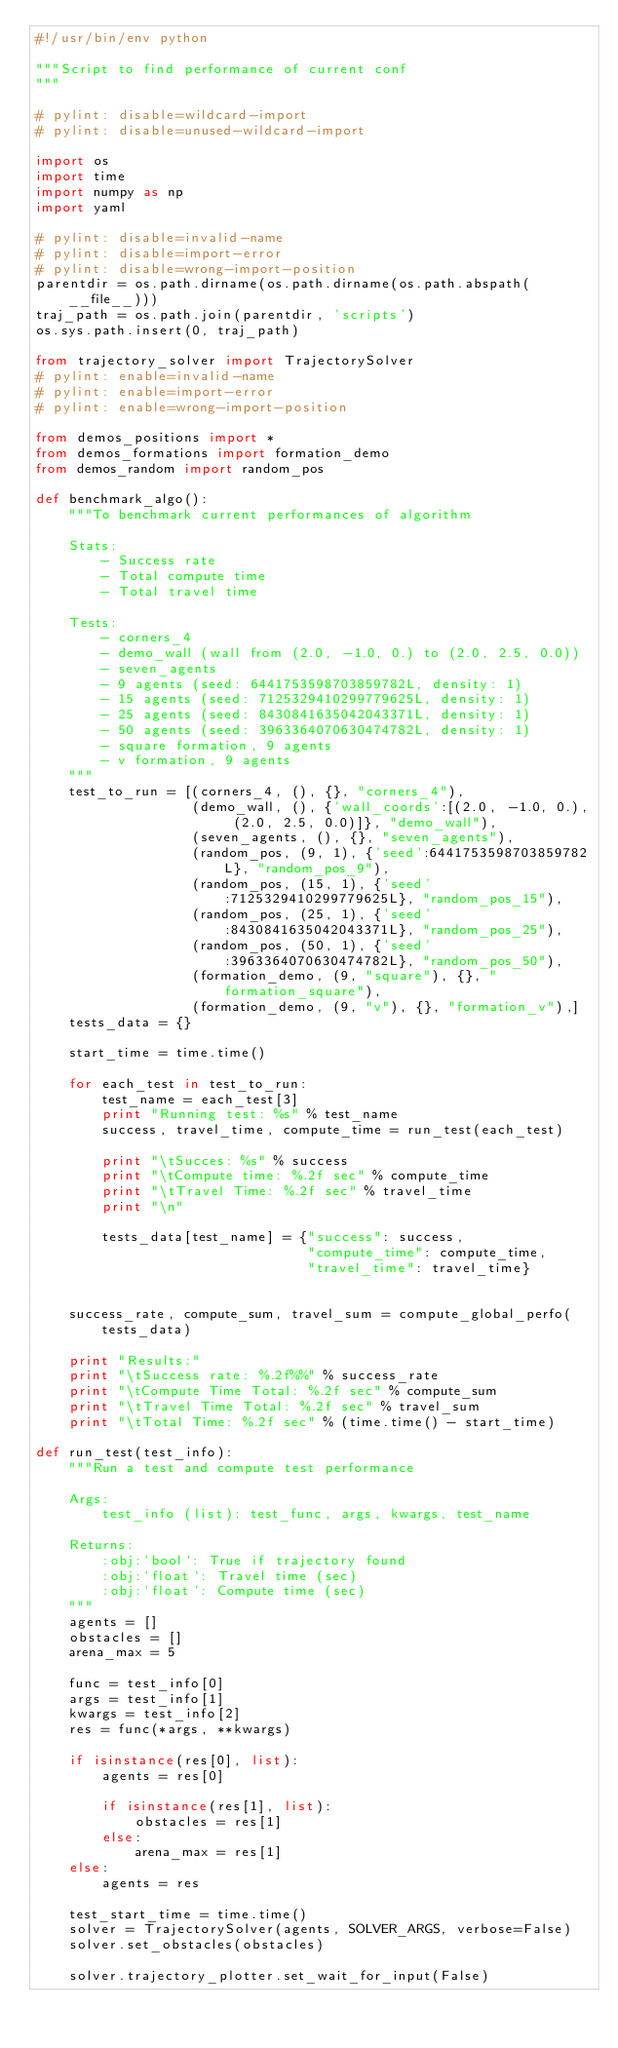Convert code to text. <code><loc_0><loc_0><loc_500><loc_500><_Python_>#!/usr/bin/env python

"""Script to find performance of current conf
"""

# pylint: disable=wildcard-import
# pylint: disable=unused-wildcard-import

import os
import time
import numpy as np
import yaml

# pylint: disable=invalid-name
# pylint: disable=import-error
# pylint: disable=wrong-import-position
parentdir = os.path.dirname(os.path.dirname(os.path.abspath(__file__)))
traj_path = os.path.join(parentdir, 'scripts')
os.sys.path.insert(0, traj_path)

from trajectory_solver import TrajectorySolver
# pylint: enable=invalid-name
# pylint: enable=import-error
# pylint: enable=wrong-import-position

from demos_positions import *
from demos_formations import formation_demo
from demos_random import random_pos

def benchmark_algo():
    """To benchmark current performances of algorithm

    Stats:
        - Success rate
        - Total compute time
        - Total travel time

    Tests:
        - corners_4
        - demo_wall (wall from (2.0, -1.0, 0.) to (2.0, 2.5, 0.0))
        - seven_agents
        - 9 agents (seed: 6441753598703859782L, density: 1)
        - 15 agents (seed: 7125329410299779625L, density: 1)
        - 25 agents (seed: 8430841635042043371L, density: 1)
        - 50 agents (seed: 3963364070630474782L, density: 1)
        - square formation, 9 agents
        - v formation, 9 agents
    """
    test_to_run = [(corners_4, (), {}, "corners_4"),
                   (demo_wall, (), {'wall_coords':[(2.0, -1.0, 0.), (2.0, 2.5, 0.0)]}, "demo_wall"),
                   (seven_agents, (), {}, "seven_agents"),
                   (random_pos, (9, 1), {'seed':6441753598703859782L}, "random_pos_9"),
                   (random_pos, (15, 1), {'seed':7125329410299779625L}, "random_pos_15"),
                   (random_pos, (25, 1), {'seed':8430841635042043371L}, "random_pos_25"),
                   (random_pos, (50, 1), {'seed':3963364070630474782L}, "random_pos_50"),
                   (formation_demo, (9, "square"), {}, "formation_square"),
                   (formation_demo, (9, "v"), {}, "formation_v"),]
    tests_data = {}

    start_time = time.time()

    for each_test in test_to_run:
        test_name = each_test[3]
        print "Running test: %s" % test_name
        success, travel_time, compute_time = run_test(each_test)

        print "\tSucces: %s" % success
        print "\tCompute time: %.2f sec" % compute_time
        print "\tTravel Time: %.2f sec" % travel_time
        print "\n"

        tests_data[test_name] = {"success": success,
                                 "compute_time": compute_time,
                                 "travel_time": travel_time}


    success_rate, compute_sum, travel_sum = compute_global_perfo(tests_data)

    print "Results:"
    print "\tSuccess rate: %.2f%%" % success_rate
    print "\tCompute Time Total: %.2f sec" % compute_sum
    print "\tTravel Time Total: %.2f sec" % travel_sum
    print "\tTotal Time: %.2f sec" % (time.time() - start_time)

def run_test(test_info):
    """Run a test and compute test performance

    Args:
        test_info (list): test_func, args, kwargs, test_name

    Returns:
        :obj:`bool`: True if trajectory found
        :obj:`float`: Travel time (sec)
        :obj:`float`: Compute time (sec)
    """
    agents = []
    obstacles = []
    arena_max = 5

    func = test_info[0]
    args = test_info[1]
    kwargs = test_info[2]
    res = func(*args, **kwargs)

    if isinstance(res[0], list):
        agents = res[0]

        if isinstance(res[1], list):
            obstacles = res[1]
        else:
            arena_max = res[1]
    else:
        agents = res

    test_start_time = time.time()
    solver = TrajectorySolver(agents, SOLVER_ARGS, verbose=False)
    solver.set_obstacles(obstacles)

    solver.trajectory_plotter.set_wait_for_input(False)</code> 